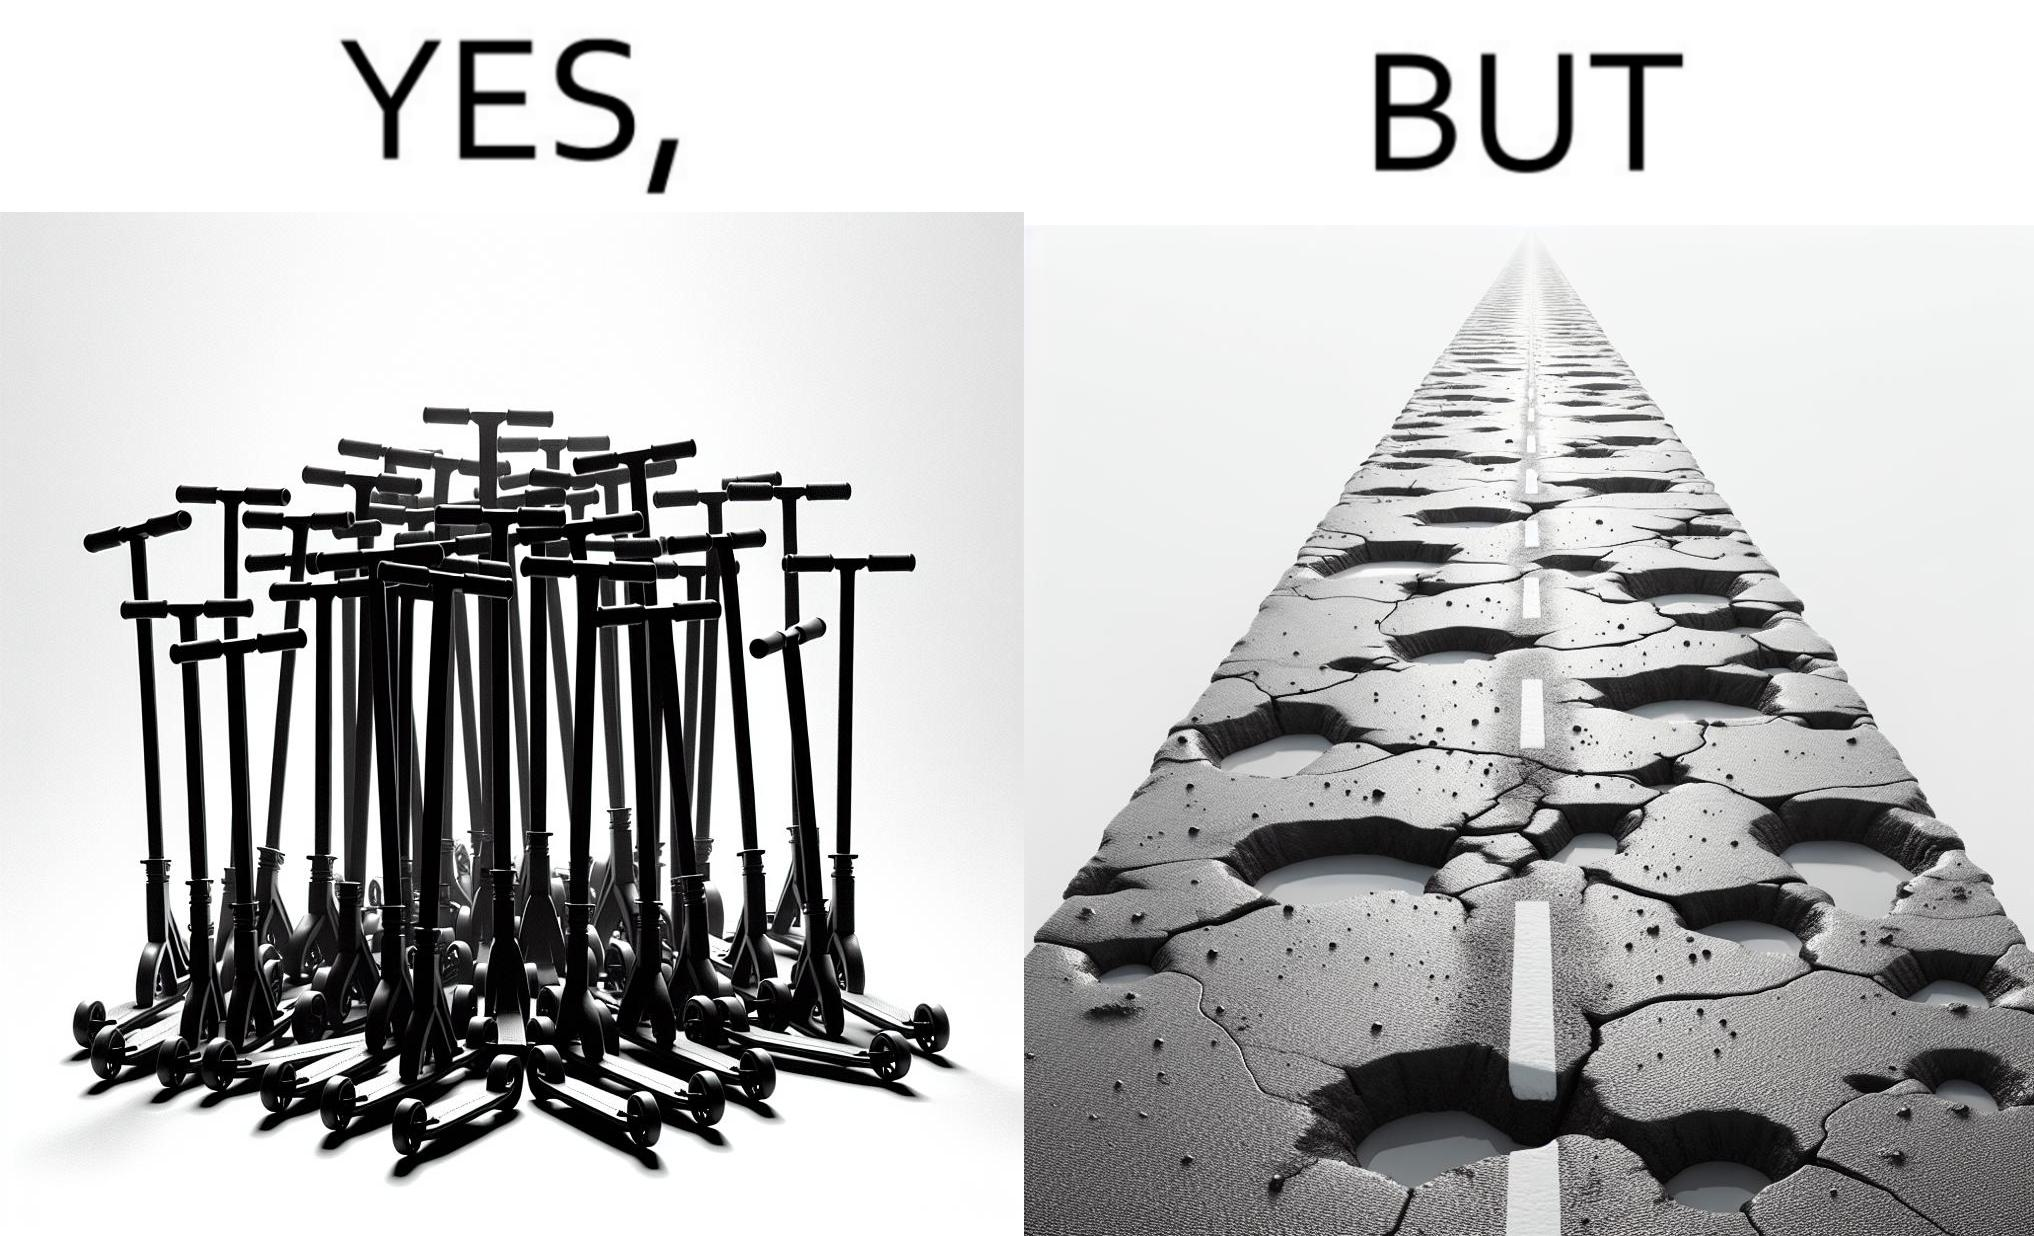What do you see in each half of this image? In the left part of the image: many skateboard scooters parked together In the right part of the image: a straight road with many potholes 